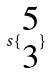Convert formula to latex. <formula><loc_0><loc_0><loc_500><loc_500>s \{ \begin{matrix} 5 \\ 3 \end{matrix} \}</formula> 